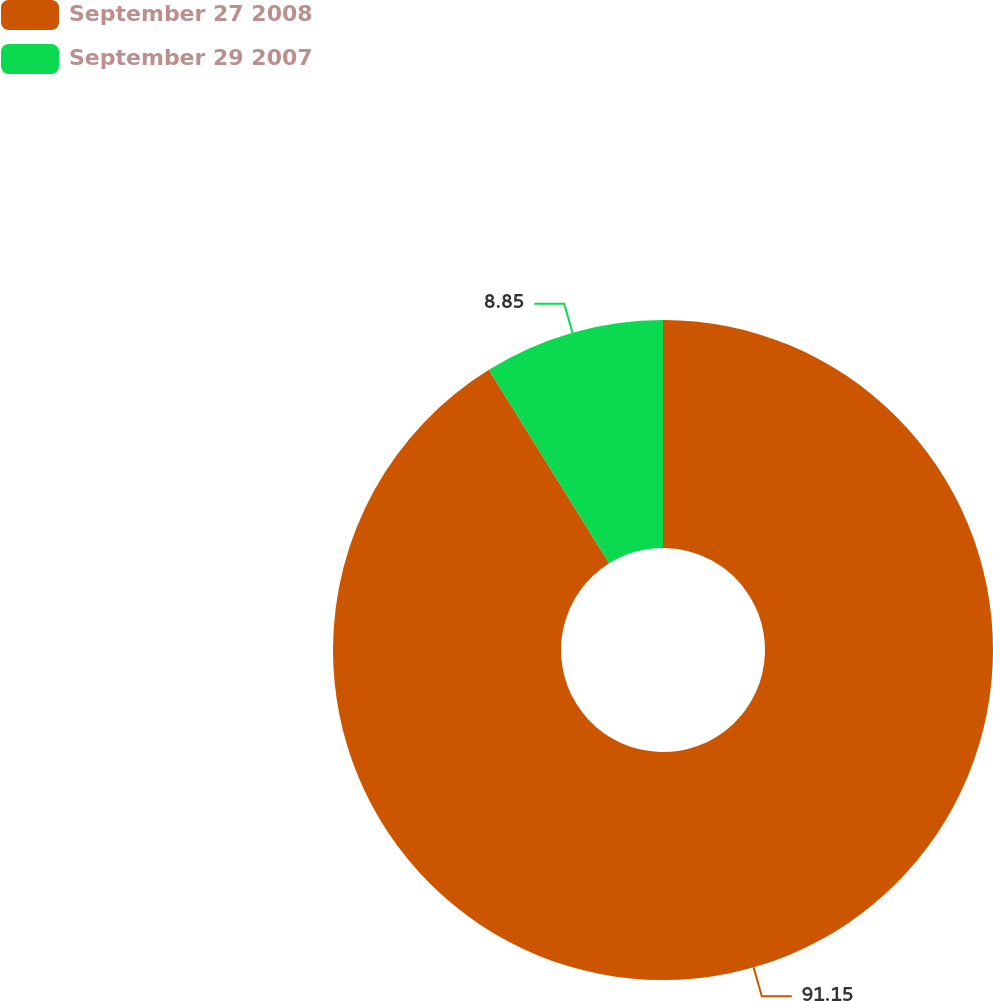Convert chart. <chart><loc_0><loc_0><loc_500><loc_500><pie_chart><fcel>September 27 2008<fcel>September 29 2007<nl><fcel>91.15%<fcel>8.85%<nl></chart> 